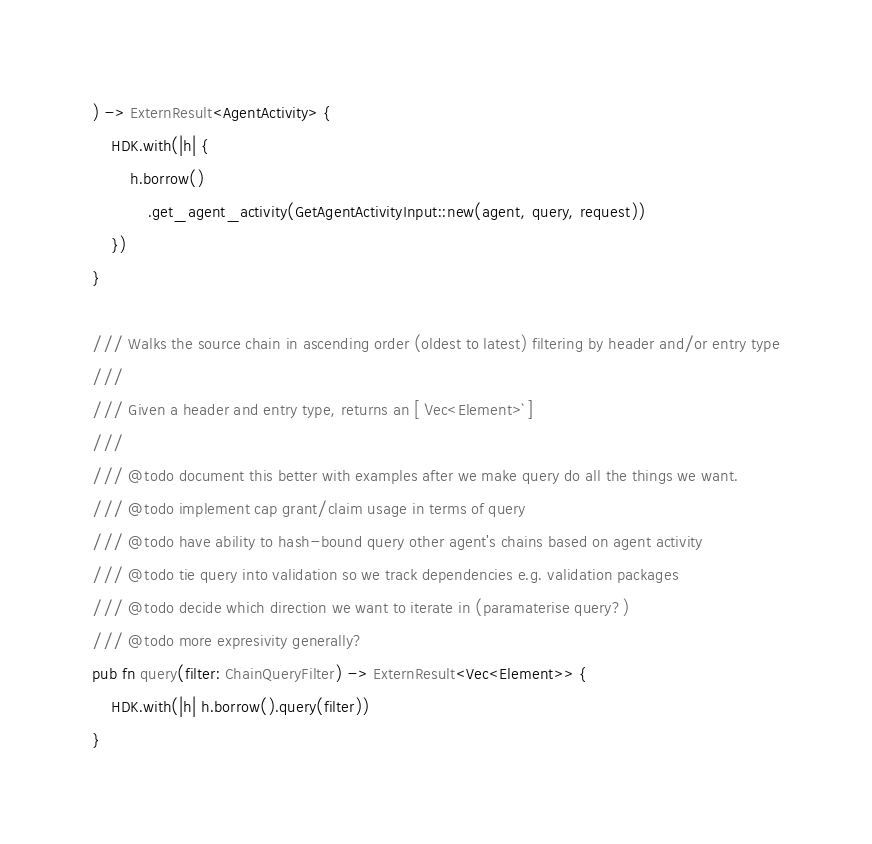Convert code to text. <code><loc_0><loc_0><loc_500><loc_500><_Rust_>) -> ExternResult<AgentActivity> {
    HDK.with(|h| {
        h.borrow()
            .get_agent_activity(GetAgentActivityInput::new(agent, query, request))
    })
}

/// Walks the source chain in ascending order (oldest to latest) filtering by header and/or entry type
///
/// Given a header and entry type, returns an [ `Vec<Element>` ]
///
/// @todo document this better with examples after we make query do all the things we want.
/// @todo implement cap grant/claim usage in terms of query
/// @todo have ability to hash-bound query other agent's chains based on agent activity
/// @todo tie query into validation so we track dependencies e.g. validation packages
/// @todo decide which direction we want to iterate in (paramaterise query?)
/// @todo more expresivity generally?
pub fn query(filter: ChainQueryFilter) -> ExternResult<Vec<Element>> {
    HDK.with(|h| h.borrow().query(filter))
}
</code> 